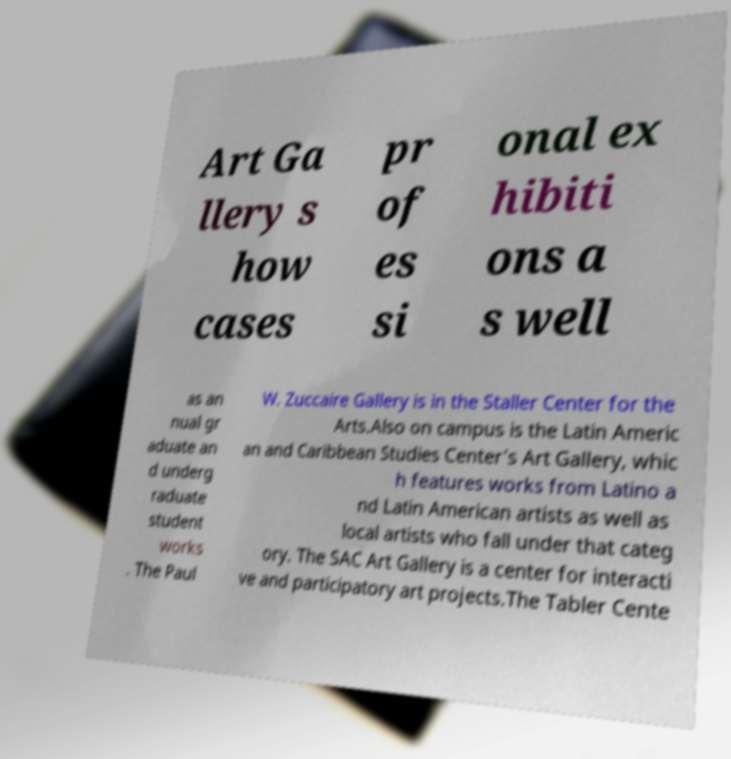Can you read and provide the text displayed in the image?This photo seems to have some interesting text. Can you extract and type it out for me? Art Ga llery s how cases pr of es si onal ex hibiti ons a s well as an nual gr aduate an d underg raduate student works . The Paul W. Zuccaire Gallery is in the Staller Center for the Arts.Also on campus is the Latin Americ an and Caribbean Studies Center's Art Gallery, whic h features works from Latino a nd Latin American artists as well as local artists who fall under that categ ory. The SAC Art Gallery is a center for interacti ve and participatory art projects.The Tabler Cente 